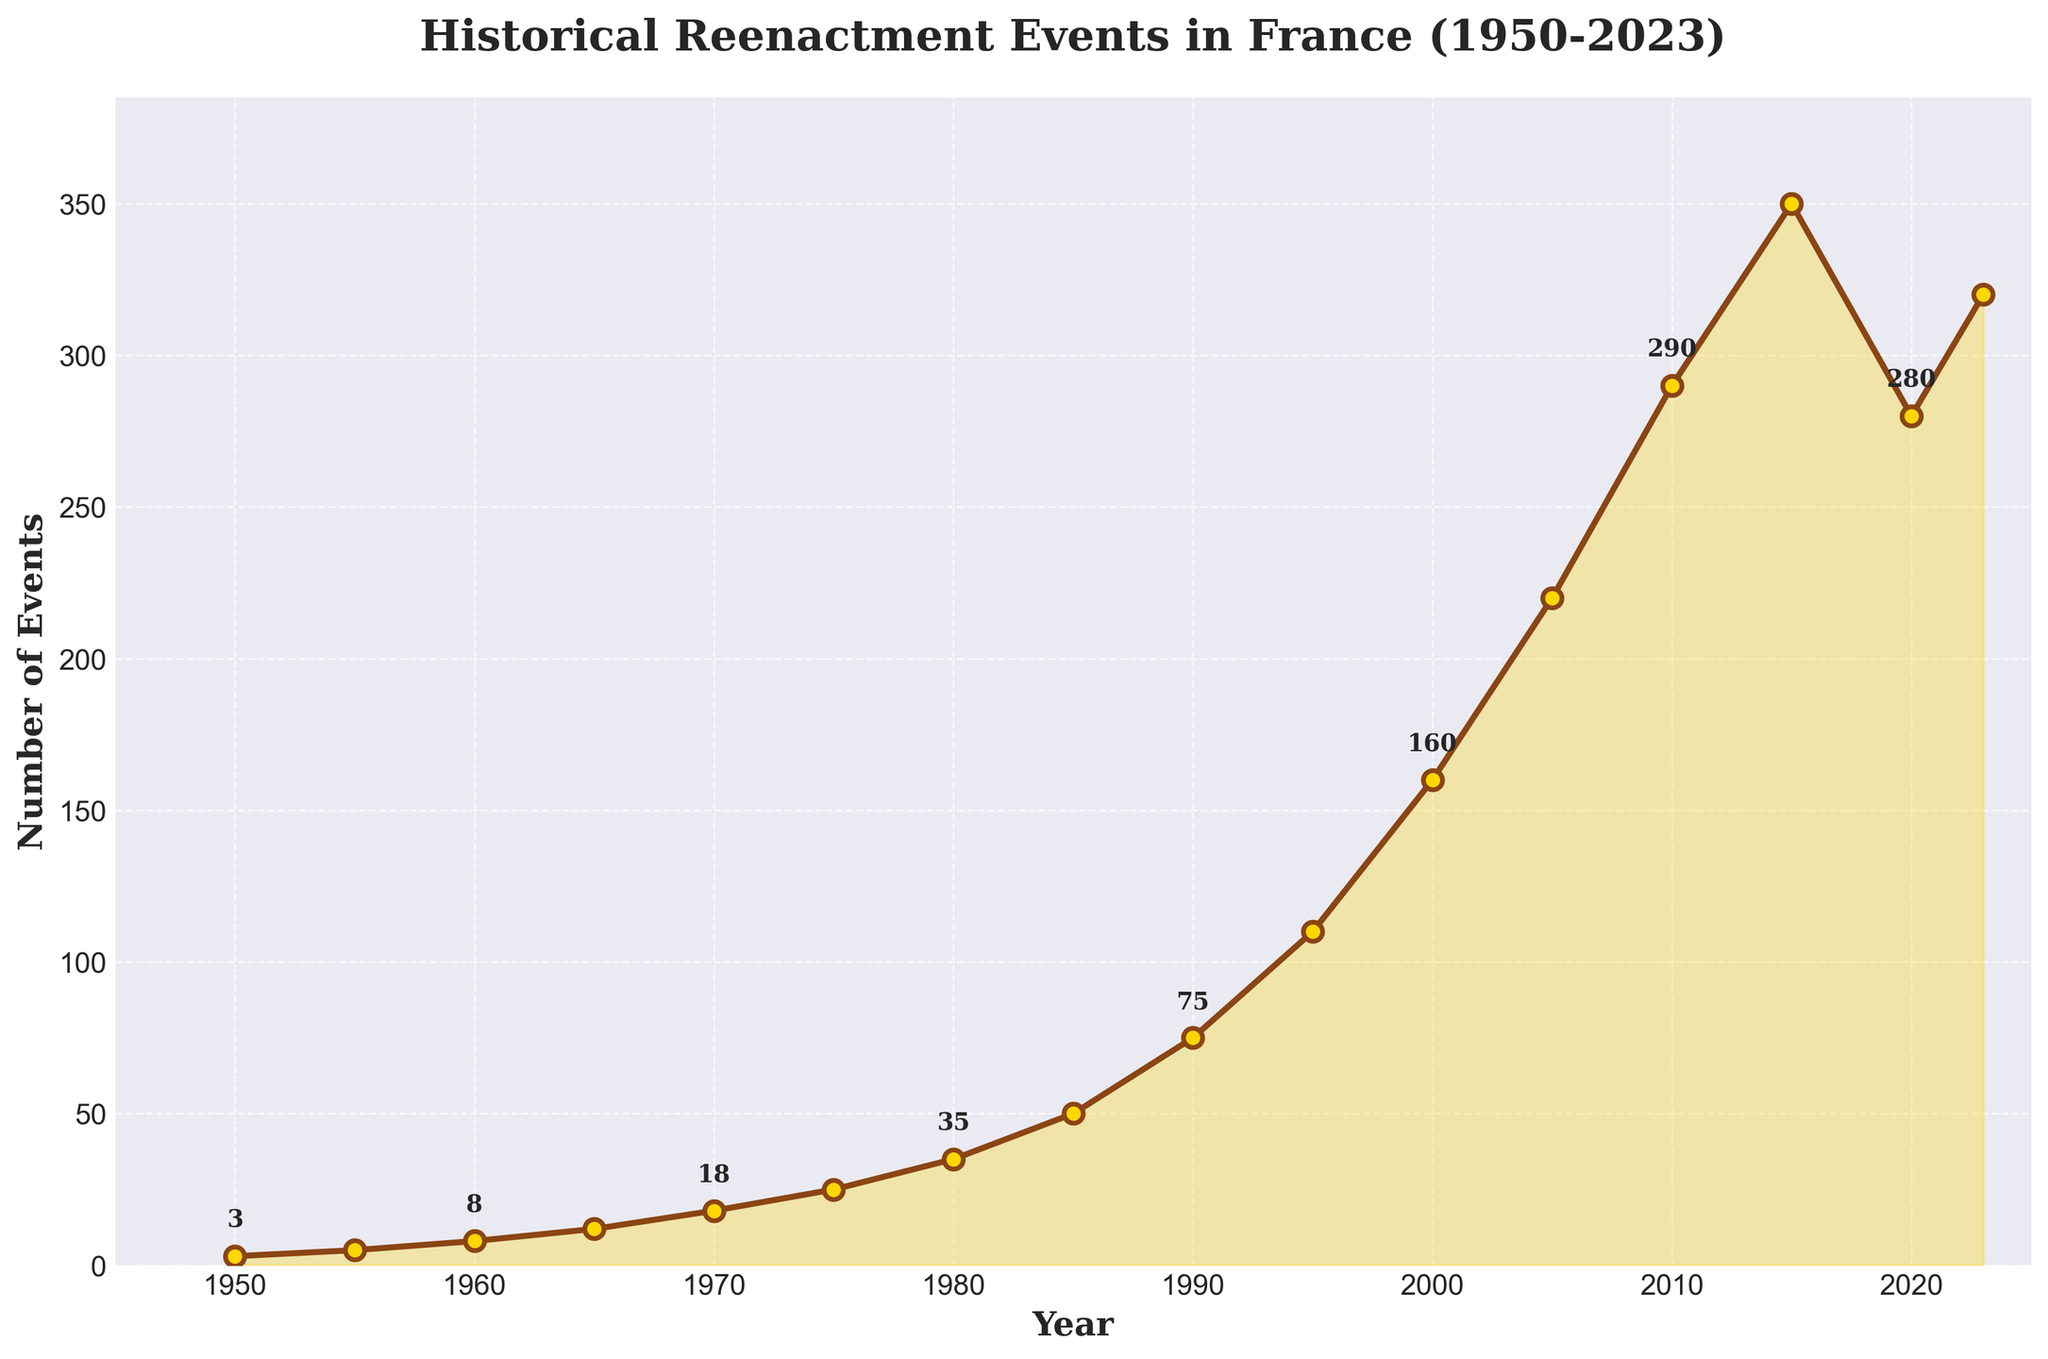Which year saw the highest number of historical reenactment events? To find the year with the highest number of events, look for the data point with the greatest vertical value on the plot. In the plot, the highest point is 350 events in 2015.
Answer: 2015 How did the number of events change from 1950 to 2023? To answer this, compare the number of events in 1950 and 2023. The number of events in 1950 was 3, and it increased to 320 by 2023, indicating a significant increase.
Answer: Increased During which decade did the steepest increase in events occur? Look at the slope of the line segments connecting points across decades. The steepest increase appears between 1990 and 2000, which shows a rise from 75 to 160 events.
Answer: 1990-2000 Compare the number of events in 2000 and 2020. Did it increase or decrease, and by how much? To determine this, subtract the number of events in 2000 from 2020. Events in 2000 were 160 and in 2020 were 280. The increase is 280 - 160.
Answer: Increased by 120 What was the average number of events per year in the 1980s? Calculate the average for the years 1980 and 1985. The number of events were 35 and 50 respectively, so the average is (35 + 50) / 2.
Answer: 42.5 Which two consecutive periods saw the number of events increase by the same amount? Look for periods where the difference in the number of events is the same. Between 2000-2005 and 2005-2010, both increments are 60 events (160 to 220 and 220 to 290).
Answer: 2000-2005 and 2005-2010 How many years took the number of events to exceed 100 for the first time? Identify the year when the number of events first exceeded 100. This occurs in 1995, which is 45 years after 1950.
Answer: 45 years Which period saw a decrease in the number of events? Look for a downward slope on the plot. The only period with a decrease is from 2015 (350 events) to 2020 (280 events).
Answer: 2015-2020 How much did the number of events increase from 1960 to 1980? Subtract the number of events in 1960 from the number in 1980. The values are 8 and 35, respectively, so the increase is 35 - 8.
Answer: 27 